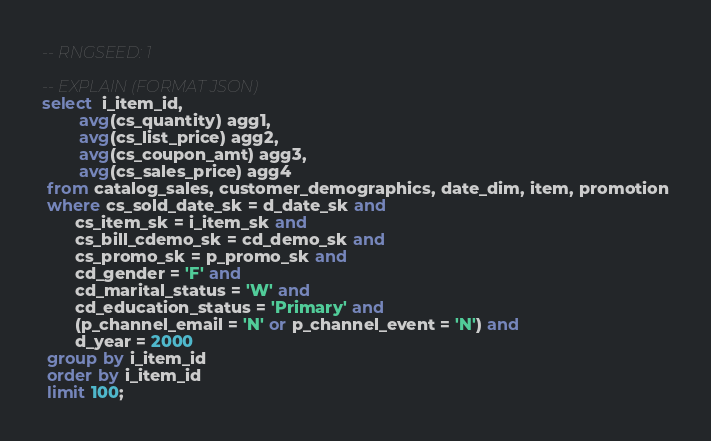<code> <loc_0><loc_0><loc_500><loc_500><_SQL_>-- RNGSEED: 1

-- EXPLAIN (FORMAT JSON)
select  i_item_id,
        avg(cs_quantity) agg1,
        avg(cs_list_price) agg2,
        avg(cs_coupon_amt) agg3,
        avg(cs_sales_price) agg4
 from catalog_sales, customer_demographics, date_dim, item, promotion
 where cs_sold_date_sk = d_date_sk and
       cs_item_sk = i_item_sk and
       cs_bill_cdemo_sk = cd_demo_sk and
       cs_promo_sk = p_promo_sk and
       cd_gender = 'F' and
       cd_marital_status = 'W' and
       cd_education_status = 'Primary' and
       (p_channel_email = 'N' or p_channel_event = 'N') and
       d_year = 2000
 group by i_item_id
 order by i_item_id
 limit 100;
</code> 